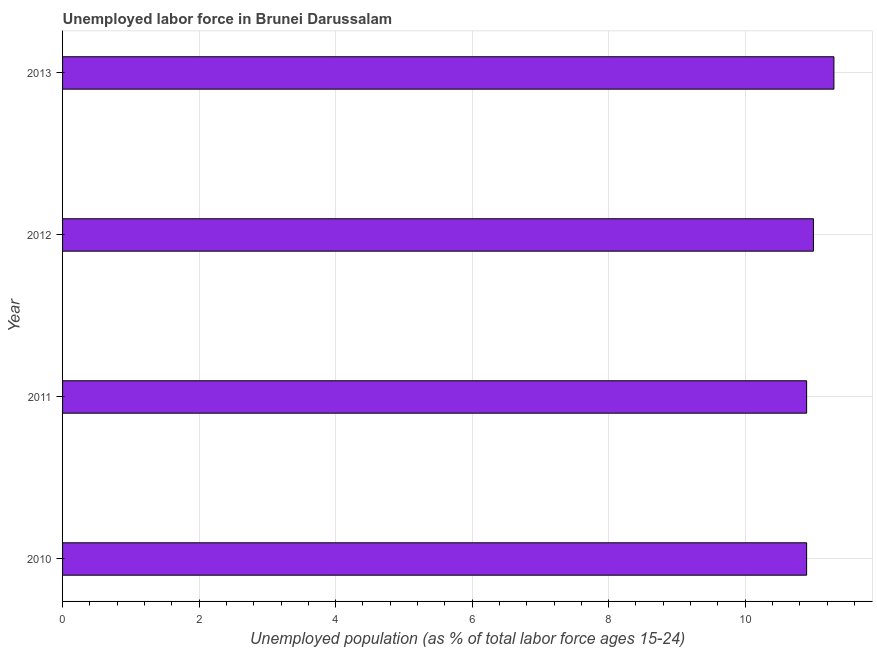Does the graph contain grids?
Ensure brevity in your answer.  Yes. What is the title of the graph?
Provide a succinct answer. Unemployed labor force in Brunei Darussalam. What is the label or title of the X-axis?
Keep it short and to the point. Unemployed population (as % of total labor force ages 15-24). What is the total unemployed youth population in 2011?
Offer a terse response. 10.9. Across all years, what is the maximum total unemployed youth population?
Your answer should be compact. 11.3. Across all years, what is the minimum total unemployed youth population?
Your answer should be compact. 10.9. In which year was the total unemployed youth population minimum?
Provide a short and direct response. 2010. What is the sum of the total unemployed youth population?
Your answer should be very brief. 44.1. What is the difference between the total unemployed youth population in 2012 and 2013?
Keep it short and to the point. -0.3. What is the average total unemployed youth population per year?
Provide a short and direct response. 11.03. What is the median total unemployed youth population?
Make the answer very short. 10.95. Do a majority of the years between 2011 and 2010 (inclusive) have total unemployed youth population greater than 9.6 %?
Offer a very short reply. No. Is the sum of the total unemployed youth population in 2012 and 2013 greater than the maximum total unemployed youth population across all years?
Provide a short and direct response. Yes. How many bars are there?
Offer a terse response. 4. How many years are there in the graph?
Make the answer very short. 4. What is the difference between two consecutive major ticks on the X-axis?
Provide a short and direct response. 2. Are the values on the major ticks of X-axis written in scientific E-notation?
Keep it short and to the point. No. What is the Unemployed population (as % of total labor force ages 15-24) of 2010?
Keep it short and to the point. 10.9. What is the Unemployed population (as % of total labor force ages 15-24) of 2011?
Offer a very short reply. 10.9. What is the Unemployed population (as % of total labor force ages 15-24) in 2012?
Your response must be concise. 11. What is the Unemployed population (as % of total labor force ages 15-24) in 2013?
Your response must be concise. 11.3. What is the difference between the Unemployed population (as % of total labor force ages 15-24) in 2010 and 2012?
Ensure brevity in your answer.  -0.1. What is the difference between the Unemployed population (as % of total labor force ages 15-24) in 2012 and 2013?
Your response must be concise. -0.3. What is the ratio of the Unemployed population (as % of total labor force ages 15-24) in 2010 to that in 2011?
Offer a terse response. 1. What is the ratio of the Unemployed population (as % of total labor force ages 15-24) in 2010 to that in 2013?
Offer a very short reply. 0.96. What is the ratio of the Unemployed population (as % of total labor force ages 15-24) in 2011 to that in 2012?
Offer a very short reply. 0.99. 